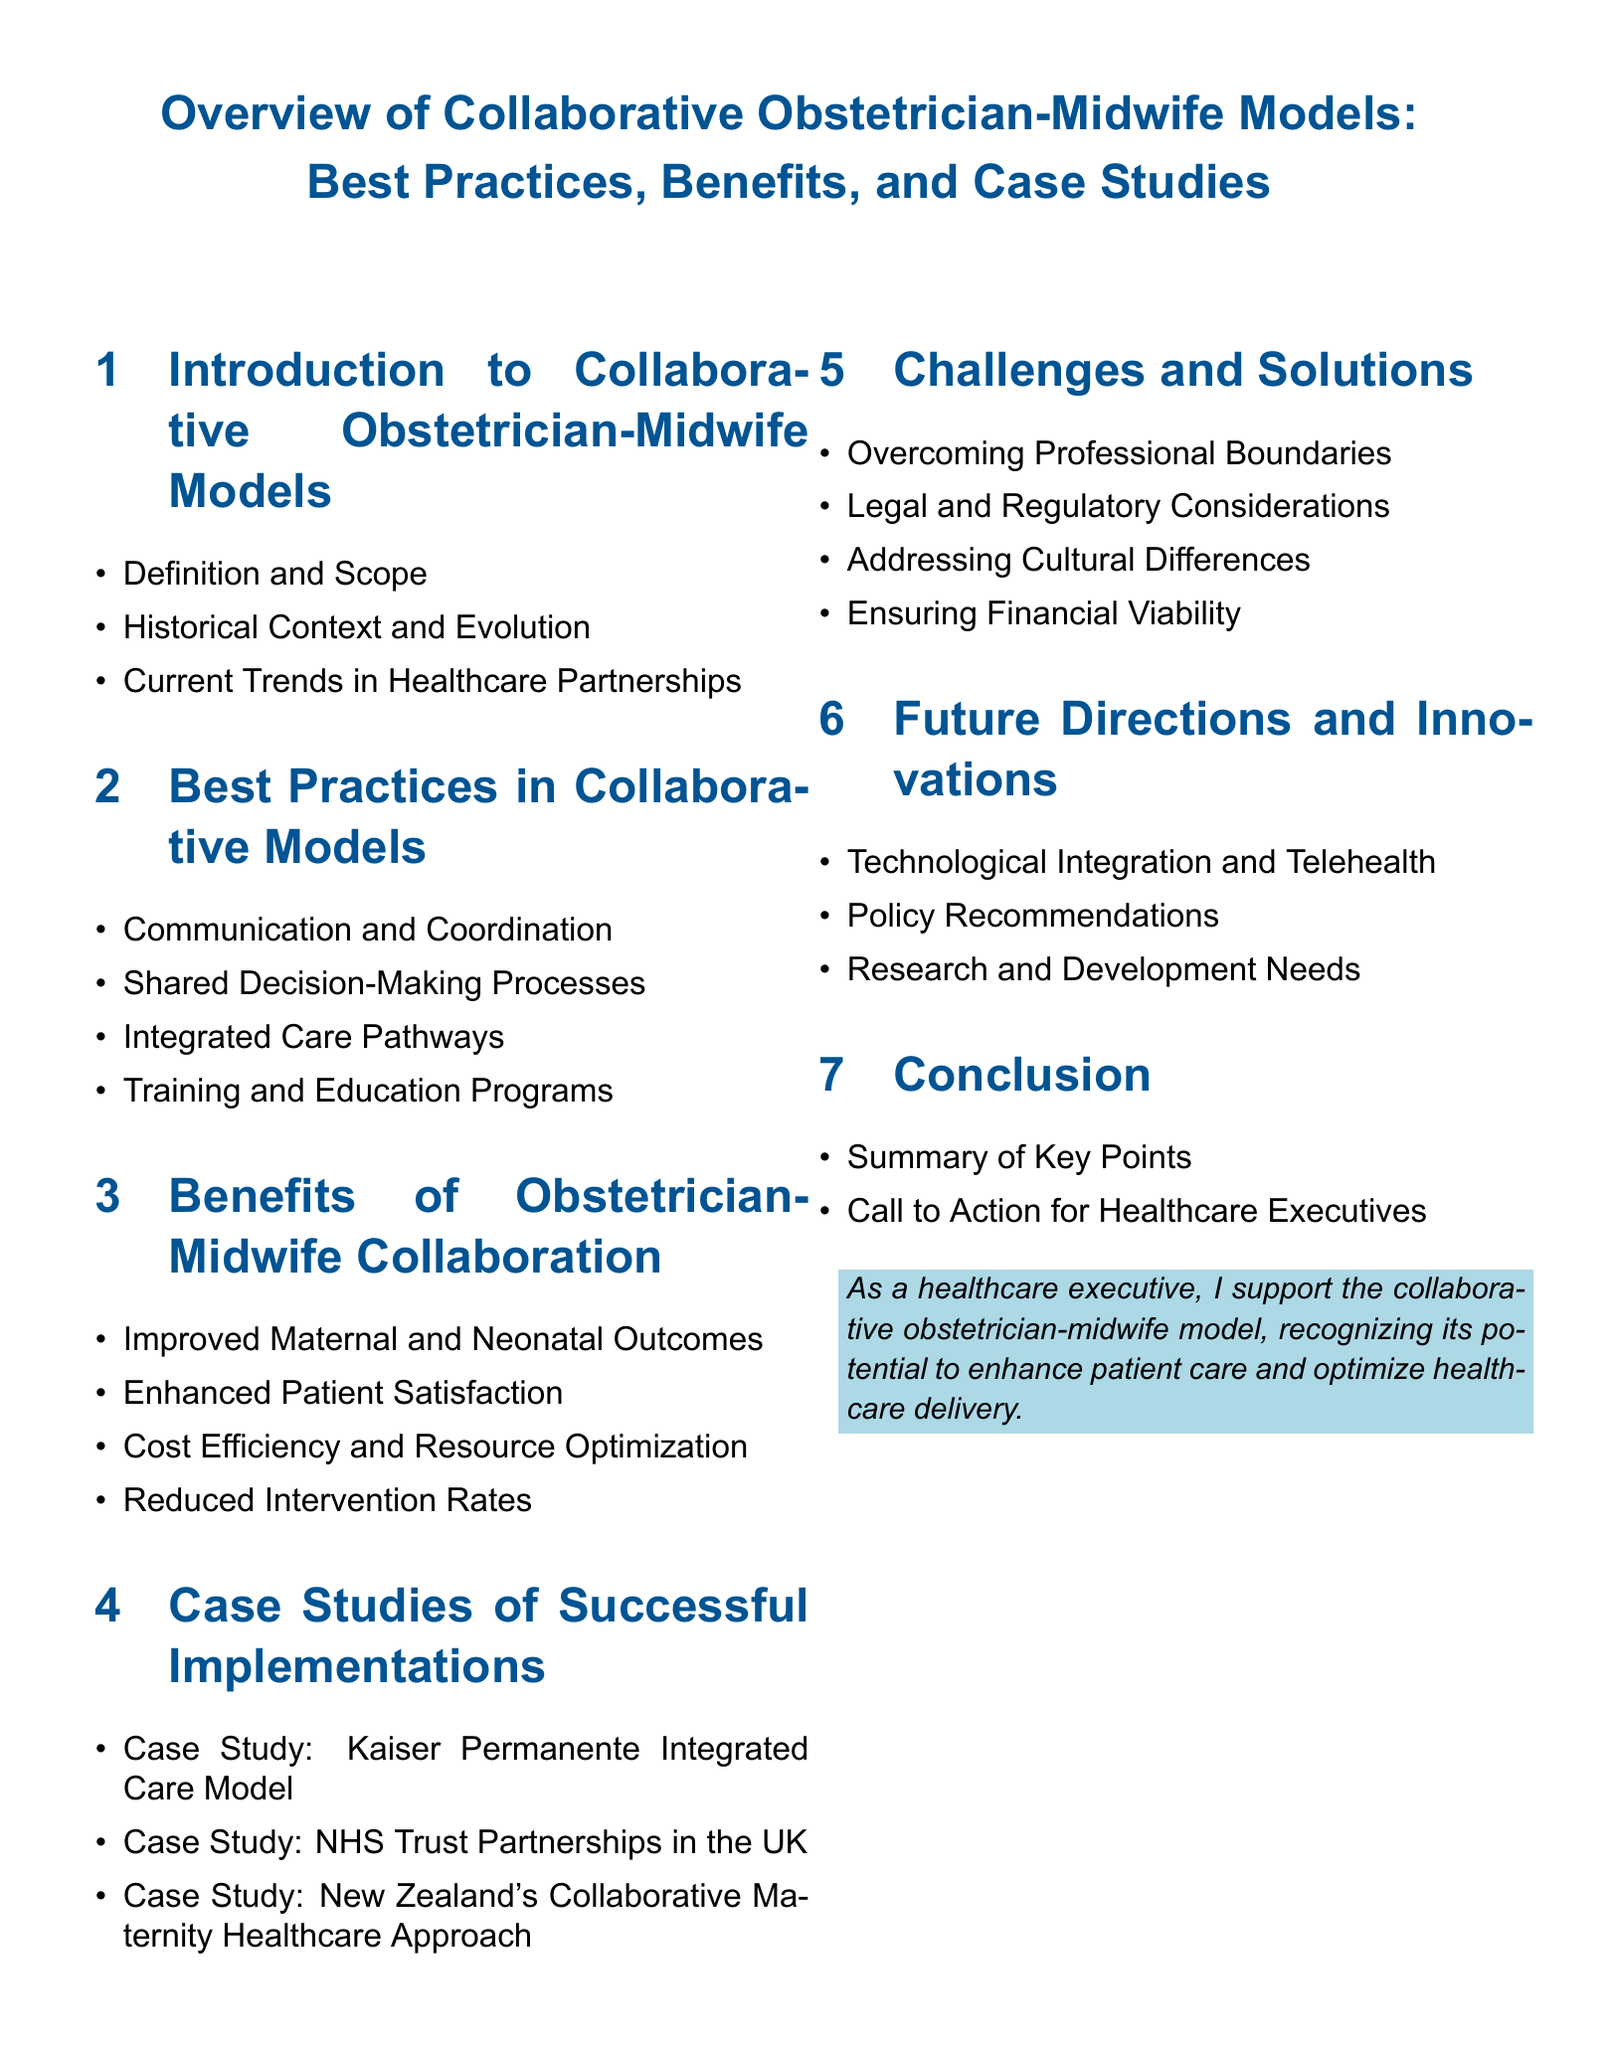What is the title of the document? The title, as displayed at the beginning of the document, is a crucial piece of information that identifies the focus of the content.
Answer: Overview of Collaborative Obstetrician-Midwife Models: Best Practices, Benefits, and Case Studies What section discusses the benefits of collaboration? This section addresses the advantages gained through collaborative efforts, which is essential for understanding the value of the model.
Answer: Benefits of Obstetrician-Midwife Collaboration How many case studies are presented in the document? The number of case studies provides insight into real-world applications of the collaborative model, highlighting its effectiveness.
Answer: Three What are the two main types of professionals in the collaborative model? Identifying the key professionals in this model helps to clarify the primary participants in the collaboration.
Answer: Obstetricians and Midwives What is one challenge mentioned in the document? Knowing the challenges is vital for recognizing areas where further support or change may be needed within the model.
Answer: Overcoming Professional Boundaries What does the summary of the conclusion aim to address? The conclusion aims to encapsulate the essential points discussed throughout the document, guiding readers on the overall message.
Answer: Key Points What technological advancement is mentioned for future directions? This question helps to identify how innovation may play a role in the evolving landscape of obstetric care within the collaborative model.
Answer: Technological Integration and Telehealth What is a best practice in collaborative models mentioned in the document? Understanding best practices is important for implementing effective collaboration strategies, ensuring quality care.
Answer: Communication and Coordination 